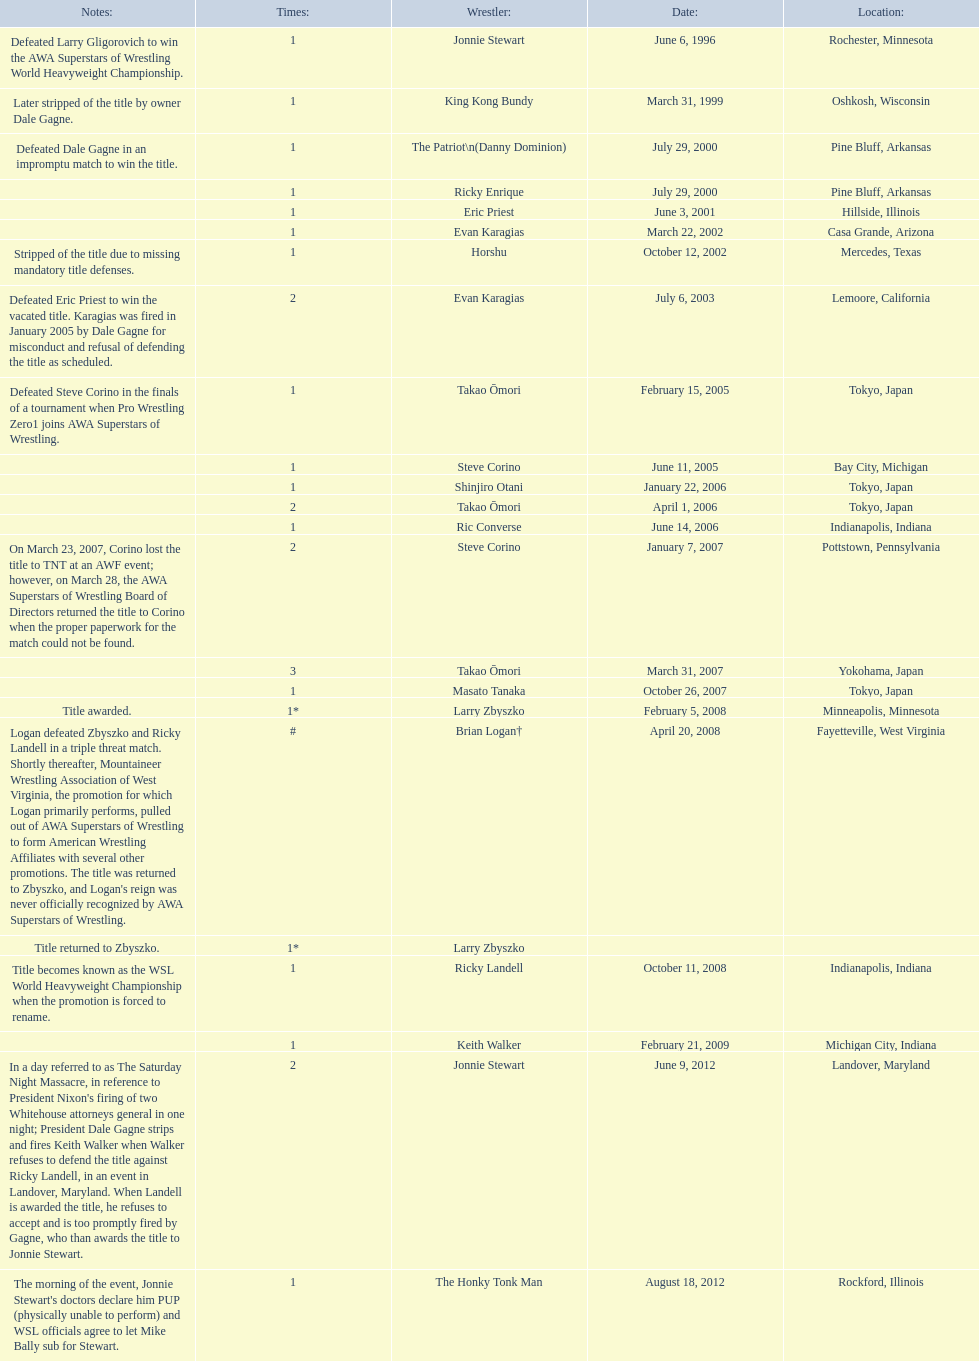Who are the wrestlers? Jonnie Stewart, Rochester, Minnesota, King Kong Bundy, Oshkosh, Wisconsin, The Patriot\n(Danny Dominion), Pine Bluff, Arkansas, Ricky Enrique, Pine Bluff, Arkansas, Eric Priest, Hillside, Illinois, Evan Karagias, Casa Grande, Arizona, Horshu, Mercedes, Texas, Evan Karagias, Lemoore, California, Takao Ōmori, Tokyo, Japan, Steve Corino, Bay City, Michigan, Shinjiro Otani, Tokyo, Japan, Takao Ōmori, Tokyo, Japan, Ric Converse, Indianapolis, Indiana, Steve Corino, Pottstown, Pennsylvania, Takao Ōmori, Yokohama, Japan, Masato Tanaka, Tokyo, Japan, Larry Zbyszko, Minneapolis, Minnesota, Brian Logan†, Fayetteville, West Virginia, Larry Zbyszko, , Ricky Landell, Indianapolis, Indiana, Keith Walker, Michigan City, Indiana, Jonnie Stewart, Landover, Maryland, The Honky Tonk Man, Rockford, Illinois. Who was from texas? Horshu, Mercedes, Texas. Who is he? Horshu. 